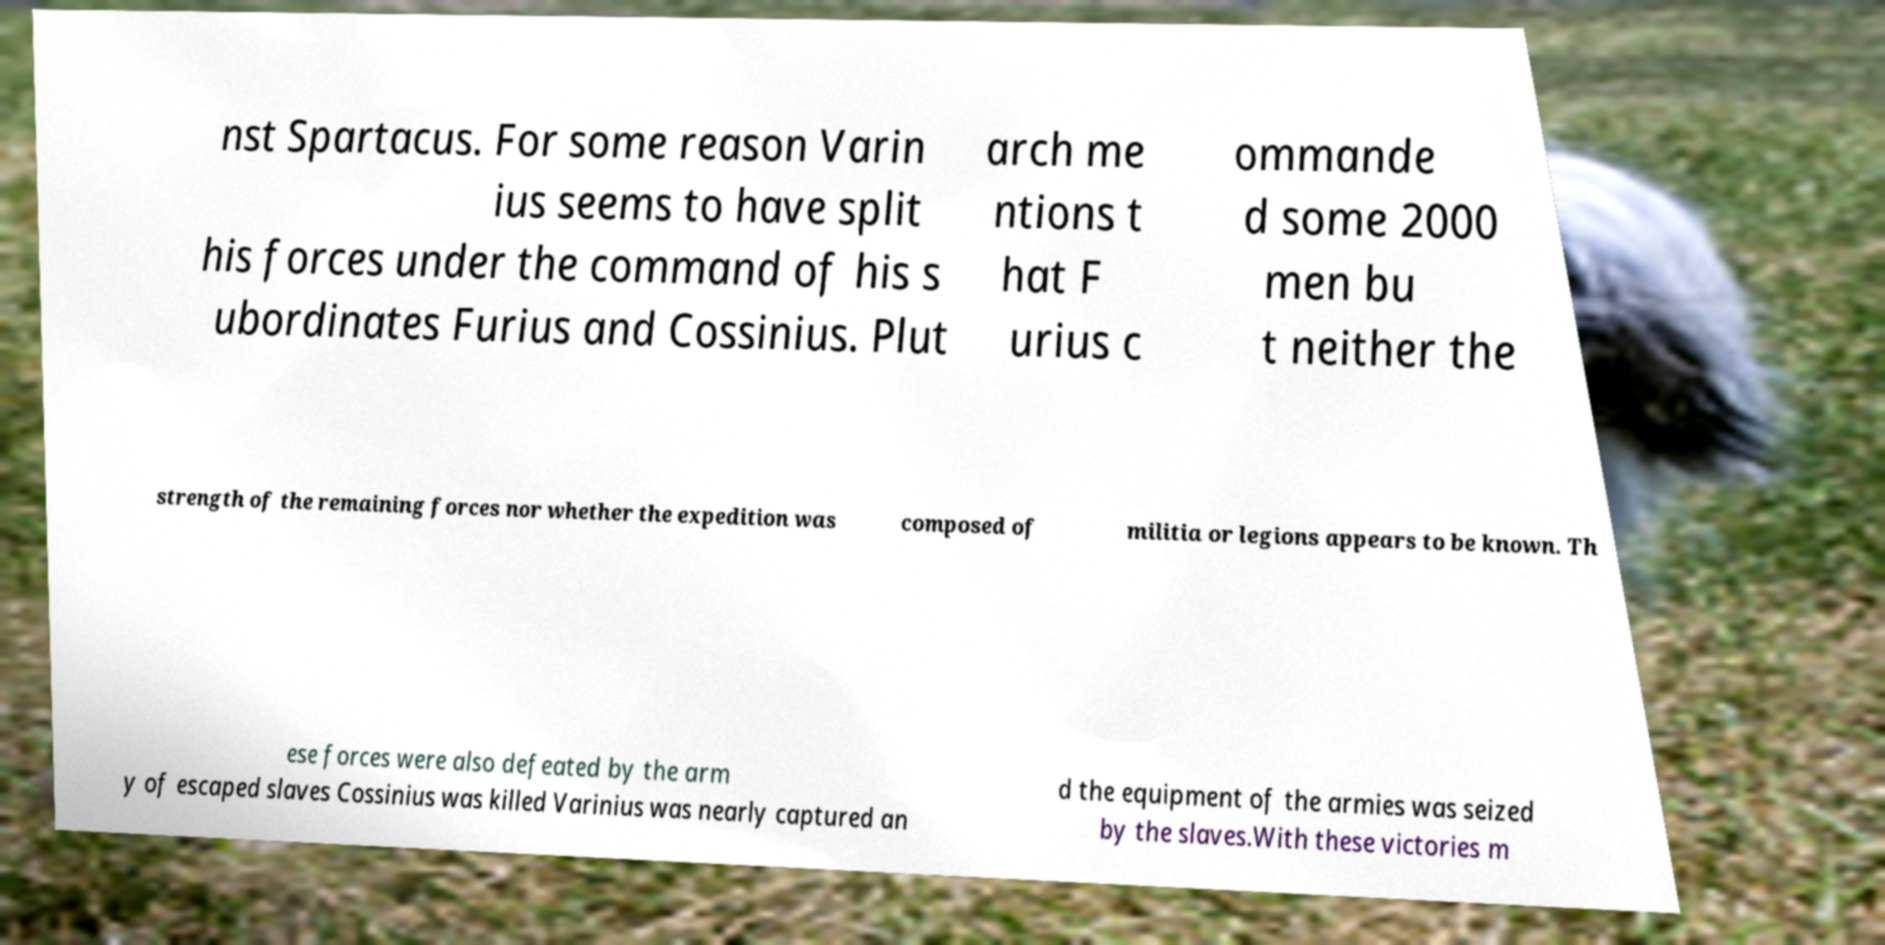Please identify and transcribe the text found in this image. nst Spartacus. For some reason Varin ius seems to have split his forces under the command of his s ubordinates Furius and Cossinius. Plut arch me ntions t hat F urius c ommande d some 2000 men bu t neither the strength of the remaining forces nor whether the expedition was composed of militia or legions appears to be known. Th ese forces were also defeated by the arm y of escaped slaves Cossinius was killed Varinius was nearly captured an d the equipment of the armies was seized by the slaves.With these victories m 